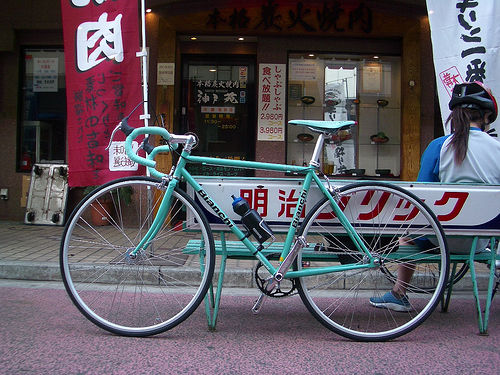<image>What does the sign say the bike is leaning on? I don't know what the sign says. It can be in Japanese, Chinese, or an assortment of other possible words. What does the sign say the bike is leaning on? I don't know what the sign says that the bike is leaning on. It can be in Japanese, Chinese or have Asian letters. 